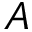<formula> <loc_0><loc_0><loc_500><loc_500>A</formula> 